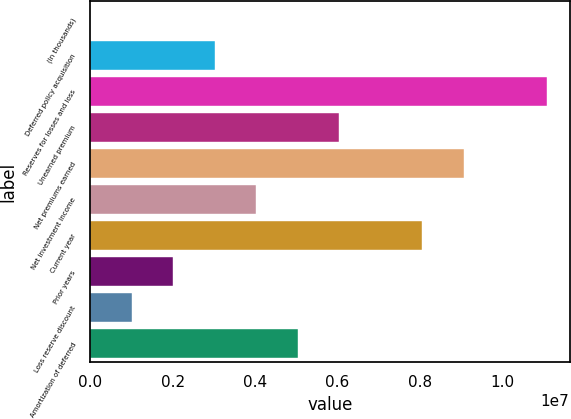Convert chart to OTSL. <chart><loc_0><loc_0><loc_500><loc_500><bar_chart><fcel>(In thousands)<fcel>Deferred policy acquisition<fcel>Reserves for losses and loss<fcel>Unearned premium<fcel>Net premiums earned<fcel>Net investment income<fcel>Current year<fcel>Prior years<fcel>Loss reserve discount<fcel>Amortization of deferred<nl><fcel>2013<fcel>3.02569e+06<fcel>1.10888e+07<fcel>6.04937e+06<fcel>9.07305e+06<fcel>4.03358e+06<fcel>8.06516e+06<fcel>2.0178e+06<fcel>1.00991e+06<fcel>5.04148e+06<nl></chart> 